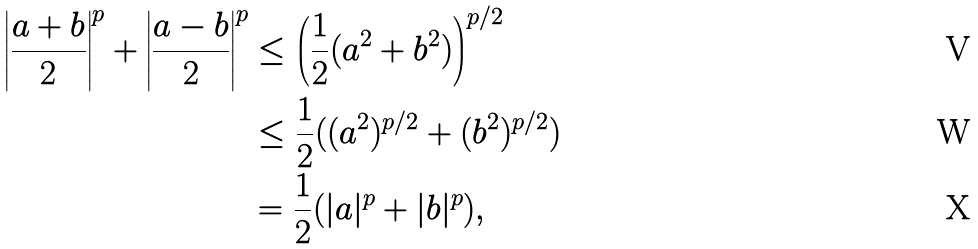Convert formula to latex. <formula><loc_0><loc_0><loc_500><loc_500>\left | \frac { a + b } 2 \right | ^ { p } + \left | \frac { a - b } 2 \right | ^ { p } & \leq \left ( \frac { 1 } { 2 } ( a ^ { 2 } + b ^ { 2 } ) \right ) ^ { p / 2 } \\ & \leq \frac { 1 } { 2 } ( ( a ^ { 2 } ) ^ { p / 2 } + ( b ^ { 2 } ) ^ { p / 2 } ) \\ & = \frac { 1 } { 2 } ( | a | ^ { p } + | b | ^ { p } ) ,</formula> 